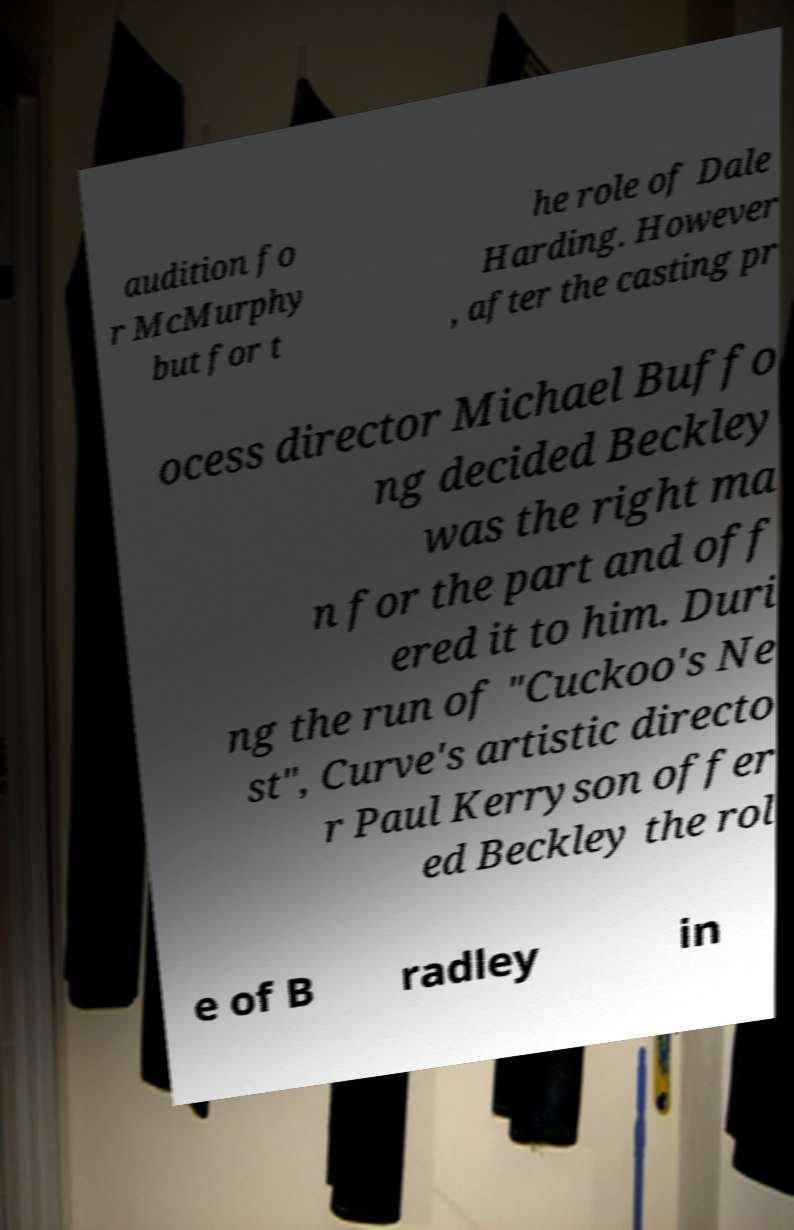Can you accurately transcribe the text from the provided image for me? audition fo r McMurphy but for t he role of Dale Harding. However , after the casting pr ocess director Michael Buffo ng decided Beckley was the right ma n for the part and off ered it to him. Duri ng the run of "Cuckoo's Ne st", Curve's artistic directo r Paul Kerryson offer ed Beckley the rol e of B radley in 